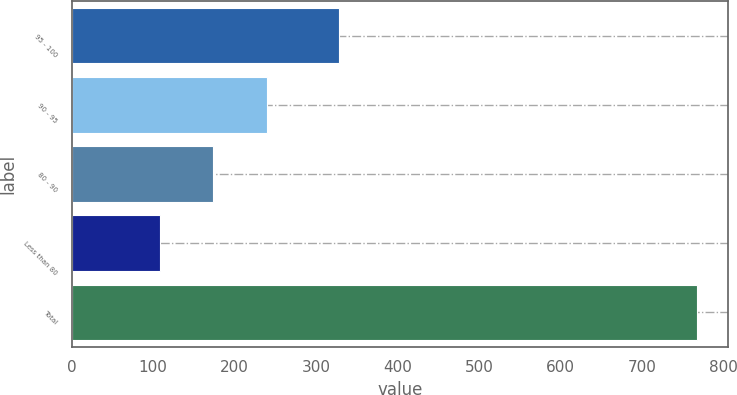Convert chart. <chart><loc_0><loc_0><loc_500><loc_500><bar_chart><fcel>95 - 100<fcel>90 - 95<fcel>80 - 90<fcel>Less than 80<fcel>Total<nl><fcel>328<fcel>239.8<fcel>173.9<fcel>108<fcel>767<nl></chart> 